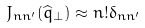Convert formula to latex. <formula><loc_0><loc_0><loc_500><loc_500>J _ { n n ^ { \prime } } ( \widehat { q } _ { \bot } ) \approx n ! \delta _ { n n ^ { \prime } }</formula> 